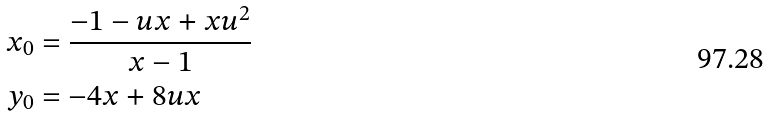<formula> <loc_0><loc_0><loc_500><loc_500>x _ { 0 } & = \frac { - 1 - u x + x u ^ { 2 } } { x - 1 } \\ y _ { 0 } & = - 4 x + 8 u x</formula> 